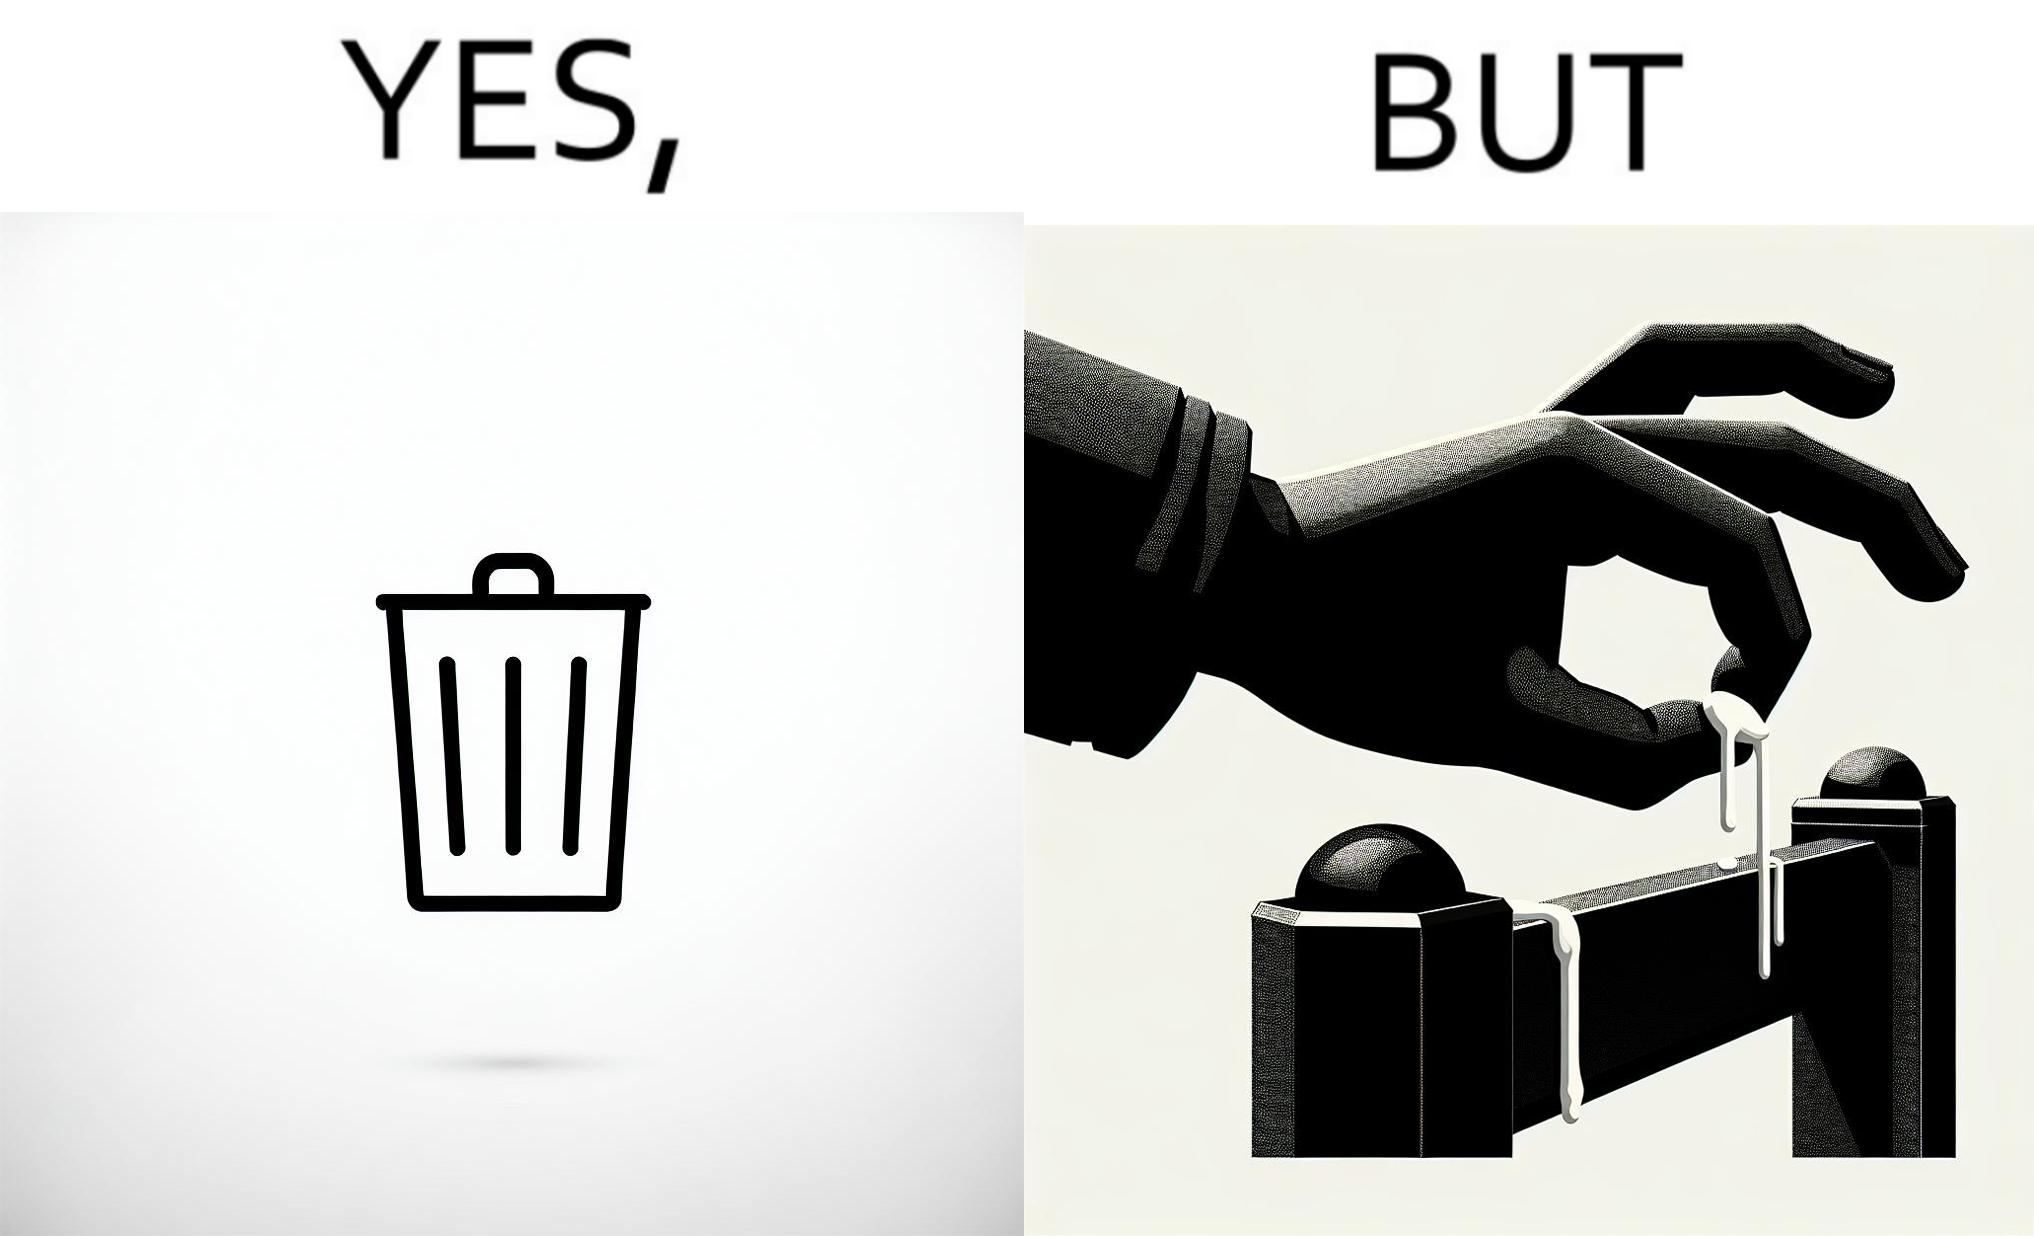Explain the humor or irony in this image. The images are ironic because even though garbage bins are provided for humans to dispose waste, by habit humans still choose to make surroundings dirty by disposing garbage improperly 